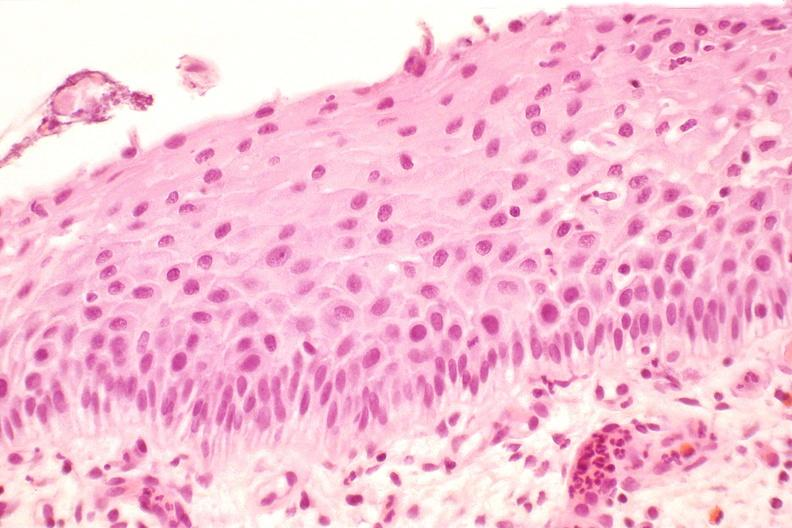does normal immature infant show cervix, mild dysplasia?
Answer the question using a single word or phrase. No 